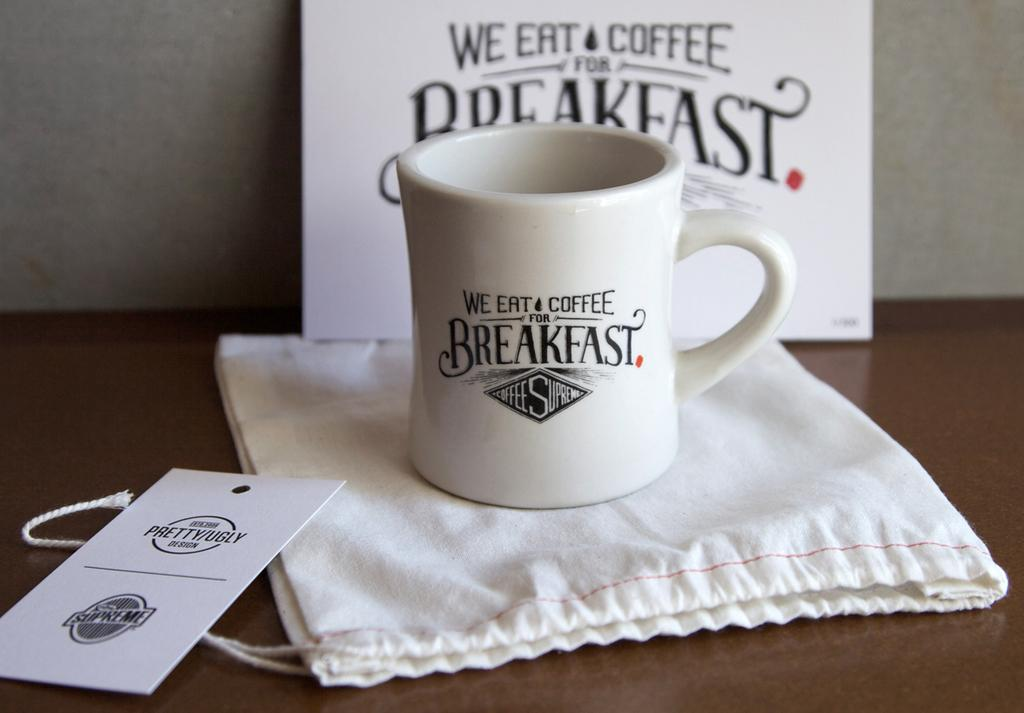<image>
Relay a brief, clear account of the picture shown. a mug, gift bag, tag, and sign for we eat coffee for breakfast 